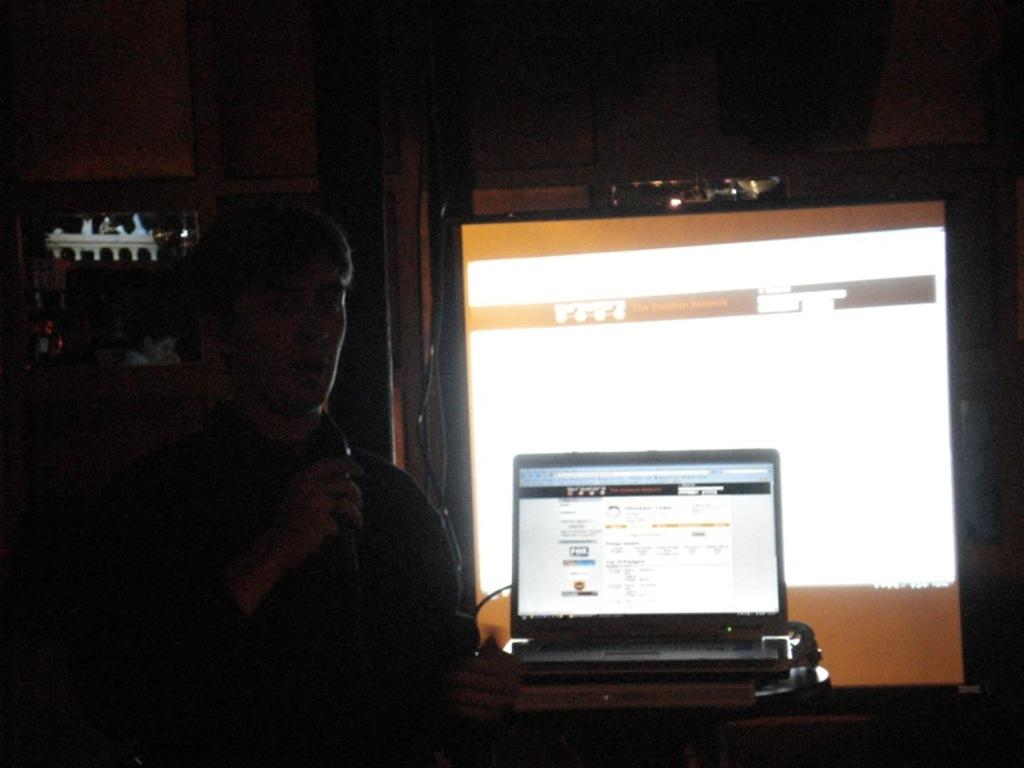What is the main subject of the image? There is a man in the image. What is the man holding in the image? The man is holding a microphone. What electronic device is present in the image? There is a laptop in the image. What type of visual display is present in the image? There are screens in the image. Can you describe the background of the image? The background of the image is dark. What type of advertisement can be seen on the canvas in the image? There is no canvas or advertisement present in the image. 